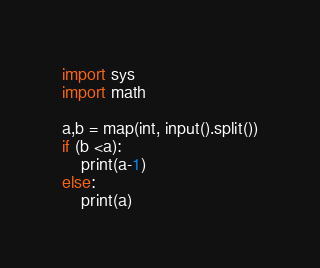<code> <loc_0><loc_0><loc_500><loc_500><_Python_>import sys
import math

a,b = map(int, input().split())
if (b <a):
    print(a-1)
else:
    print(a)</code> 